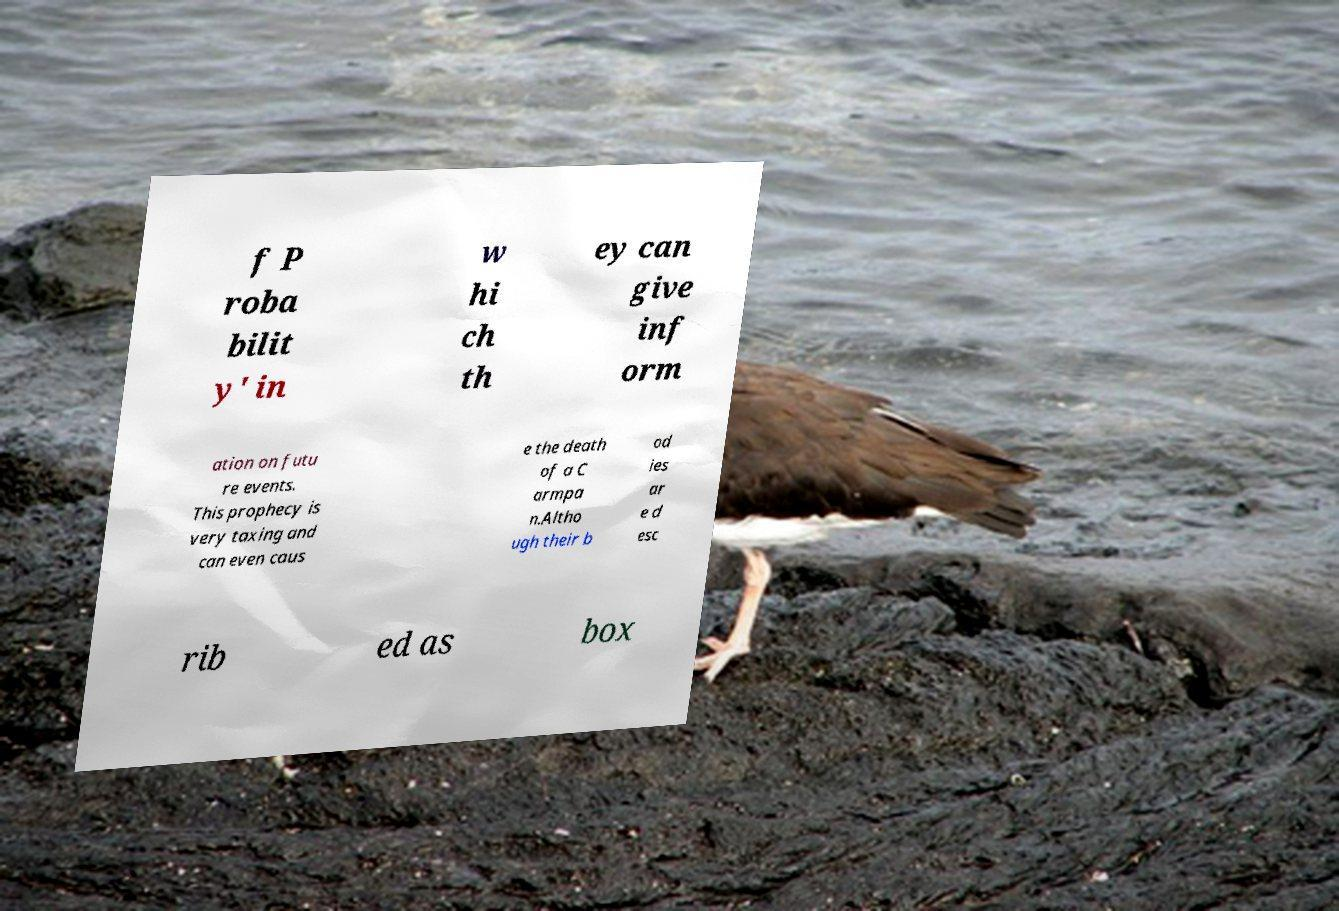There's text embedded in this image that I need extracted. Can you transcribe it verbatim? f P roba bilit y' in w hi ch th ey can give inf orm ation on futu re events. This prophecy is very taxing and can even caus e the death of a C armpa n.Altho ugh their b od ies ar e d esc rib ed as box 